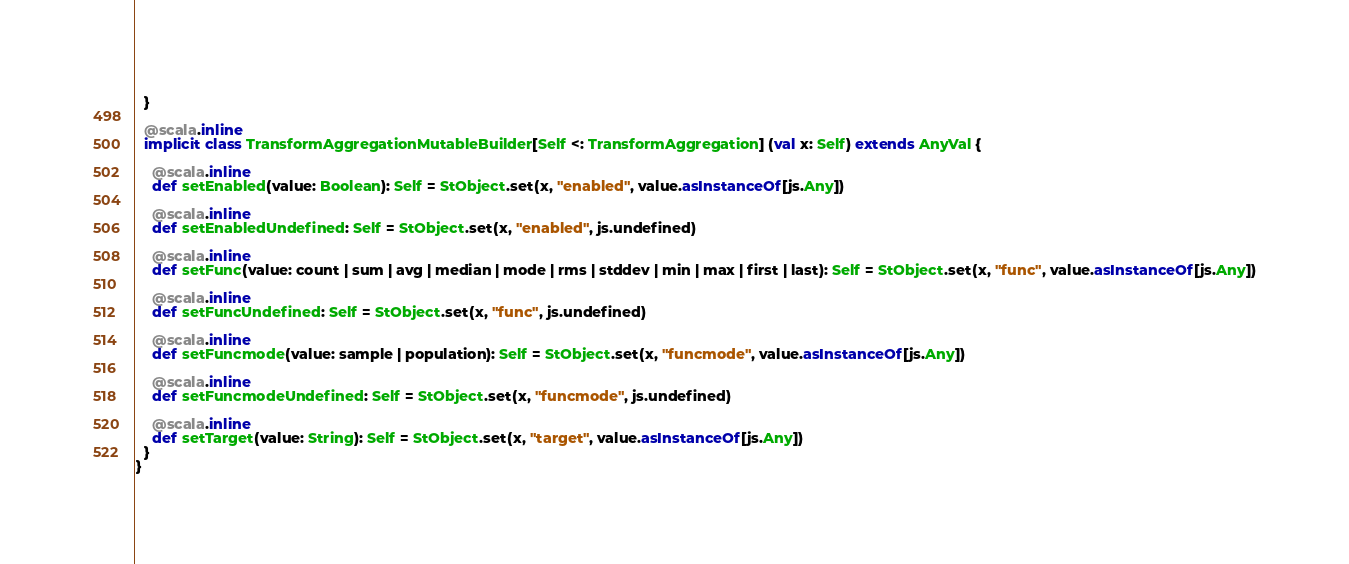<code> <loc_0><loc_0><loc_500><loc_500><_Scala_>  }
  
  @scala.inline
  implicit class TransformAggregationMutableBuilder[Self <: TransformAggregation] (val x: Self) extends AnyVal {
    
    @scala.inline
    def setEnabled(value: Boolean): Self = StObject.set(x, "enabled", value.asInstanceOf[js.Any])
    
    @scala.inline
    def setEnabledUndefined: Self = StObject.set(x, "enabled", js.undefined)
    
    @scala.inline
    def setFunc(value: count | sum | avg | median | mode | rms | stddev | min | max | first | last): Self = StObject.set(x, "func", value.asInstanceOf[js.Any])
    
    @scala.inline
    def setFuncUndefined: Self = StObject.set(x, "func", js.undefined)
    
    @scala.inline
    def setFuncmode(value: sample | population): Self = StObject.set(x, "funcmode", value.asInstanceOf[js.Any])
    
    @scala.inline
    def setFuncmodeUndefined: Self = StObject.set(x, "funcmode", js.undefined)
    
    @scala.inline
    def setTarget(value: String): Self = StObject.set(x, "target", value.asInstanceOf[js.Any])
  }
}
</code> 